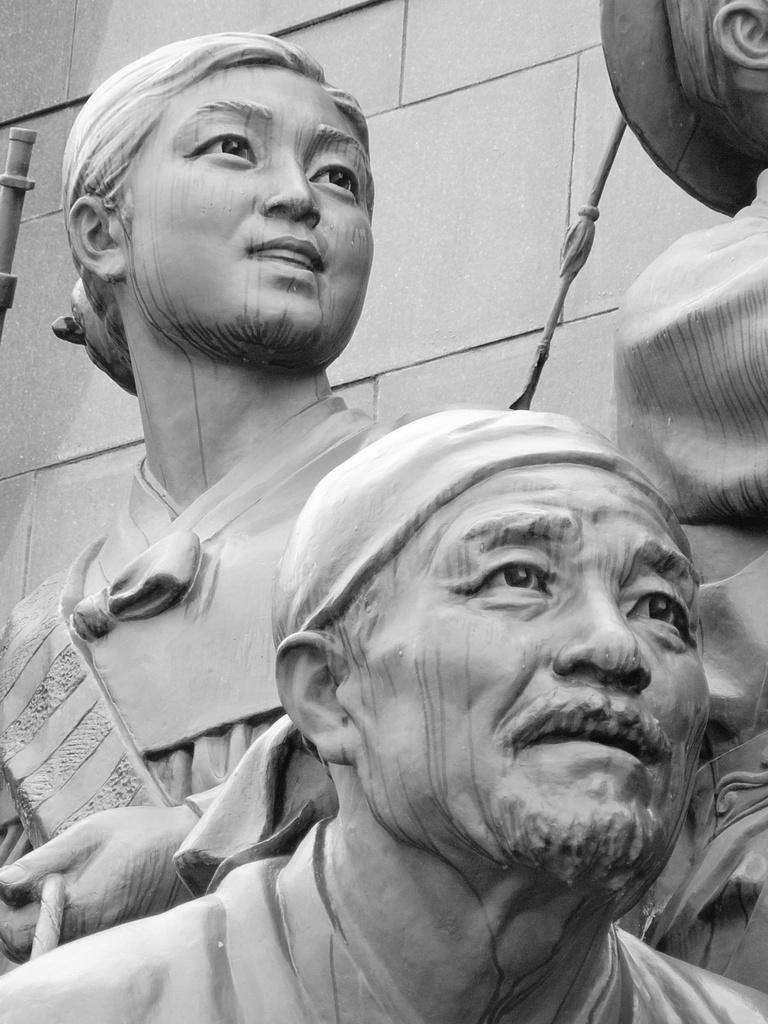What type of objects are depicted in the image? There are two statues of humans in the image. What is the color scheme of the image? The image is black and white. What can be seen in the background of the image? There is a wall in the background of the image. What type of country is depicted in the image? There is no country depicted in the image; it features two statues of humans and a wall in the background. What type of farming equipment can be seen in the image? There is no farming equipment, such as a plough or yoke, present in the image. 